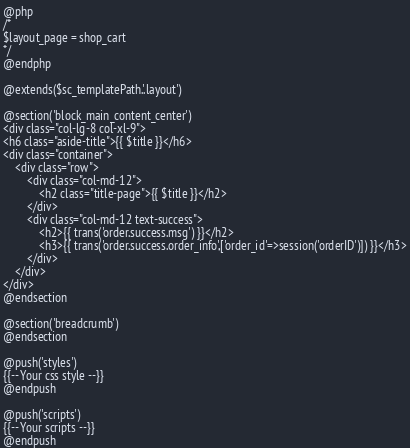<code> <loc_0><loc_0><loc_500><loc_500><_PHP_>@php
/*
$layout_page = shop_cart
*/
@endphp

@extends($sc_templatePath.'.layout')

@section('block_main_content_center')
<div class="col-lg-8 col-xl-9">
<h6 class="aside-title">{{ $title }}</h6>
<div class="container">
    <div class="row">
        <div class="col-md-12">
            <h2 class="title-page">{{ $title }}</h2>
        </div>
        <div class="col-md-12 text-success">
            <h2>{{ trans('order.success.msg') }}</h2>
            <h3>{{ trans('order.success.order_info',['order_id'=>session('orderID')]) }}</h3>
        </div>
    </div>
</div>
@endsection

@section('breadcrumb')
@endsection

@push('styles')
{{-- Your css style --}}
@endpush

@push('scripts')
{{-- Your scripts --}}
@endpush</code> 